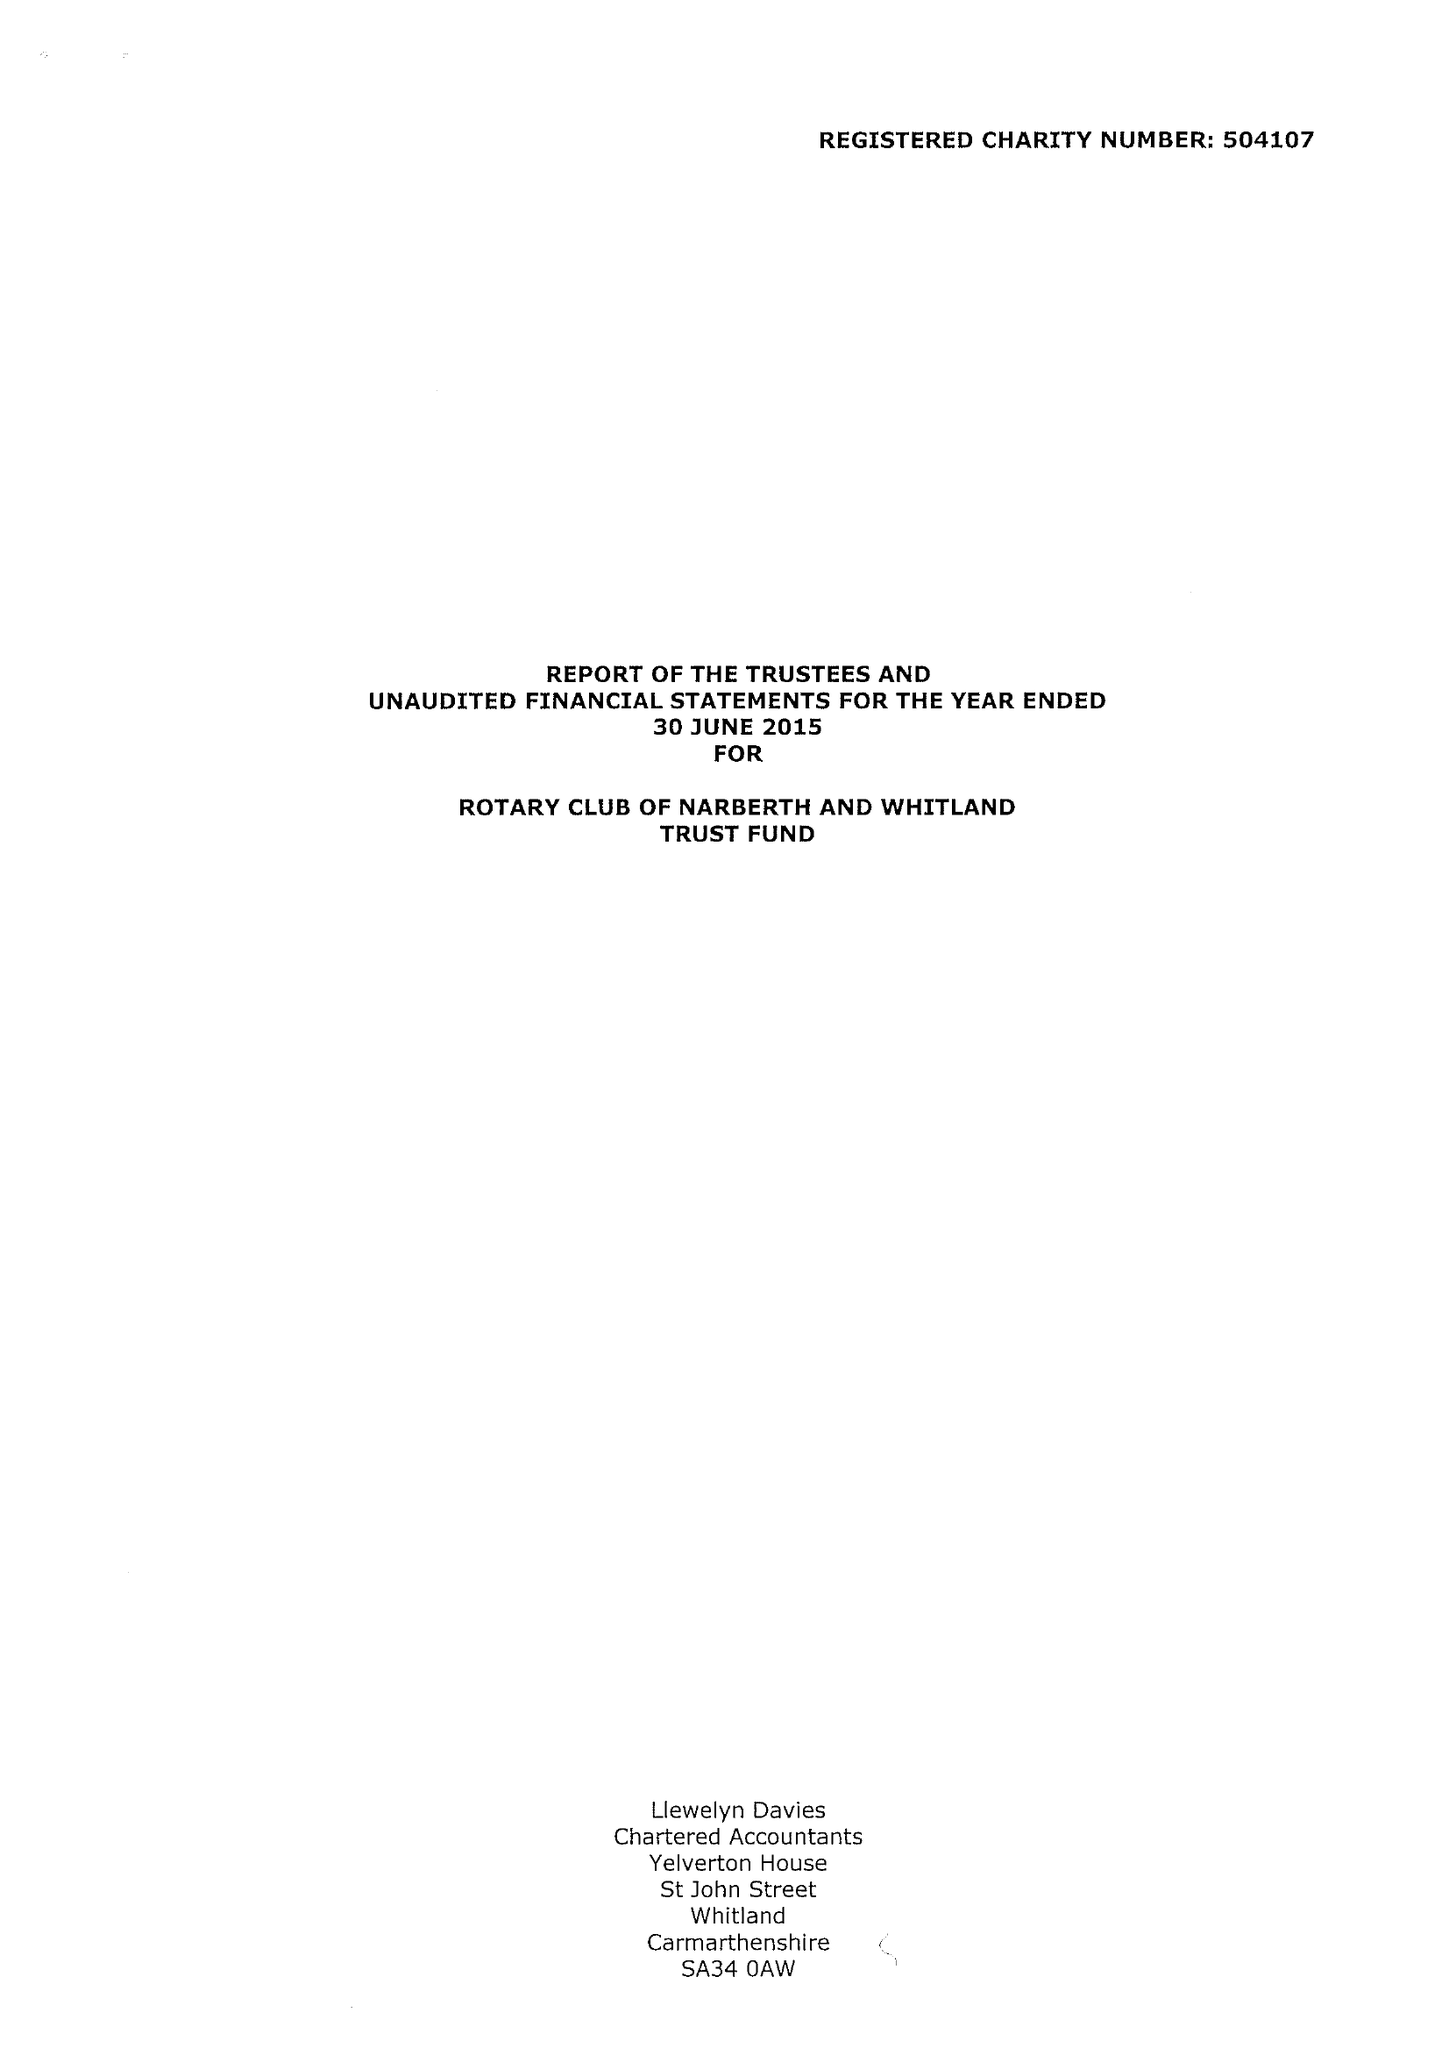What is the value for the income_annually_in_british_pounds?
Answer the question using a single word or phrase. 34409.00 